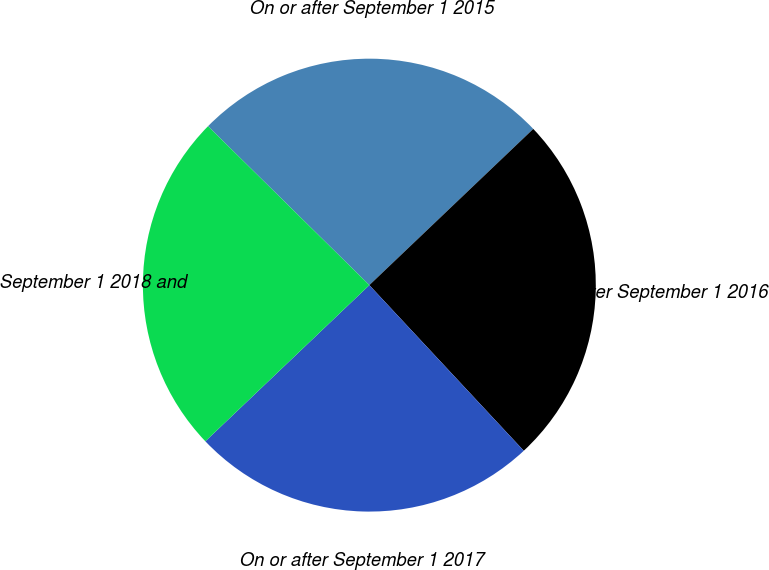Convert chart to OTSL. <chart><loc_0><loc_0><loc_500><loc_500><pie_chart><fcel>On or after September 1 2015<fcel>On or after September 1 2016<fcel>On or after September 1 2017<fcel>September 1 2018 and<nl><fcel>25.5%<fcel>25.17%<fcel>24.83%<fcel>24.49%<nl></chart> 